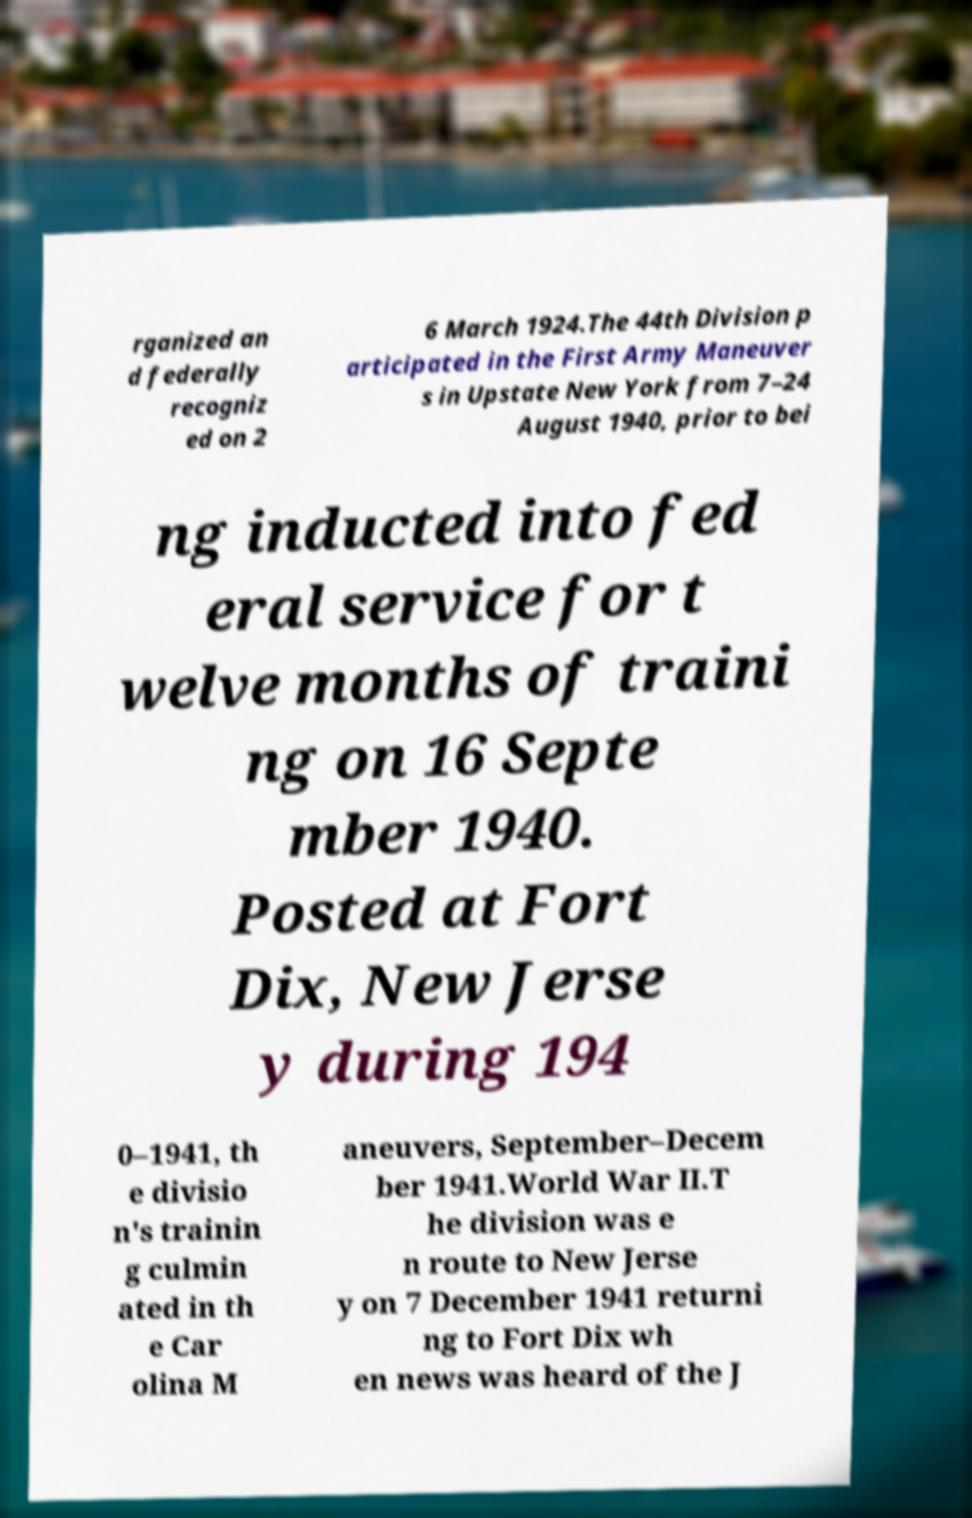What messages or text are displayed in this image? I need them in a readable, typed format. rganized an d federally recogniz ed on 2 6 March 1924.The 44th Division p articipated in the First Army Maneuver s in Upstate New York from 7–24 August 1940, prior to bei ng inducted into fed eral service for t welve months of traini ng on 16 Septe mber 1940. Posted at Fort Dix, New Jerse y during 194 0–1941, th e divisio n's trainin g culmin ated in th e Car olina M aneuvers, September–Decem ber 1941.World War II.T he division was e n route to New Jerse y on 7 December 1941 returni ng to Fort Dix wh en news was heard of the J 